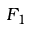<formula> <loc_0><loc_0><loc_500><loc_500>F _ { 1 }</formula> 